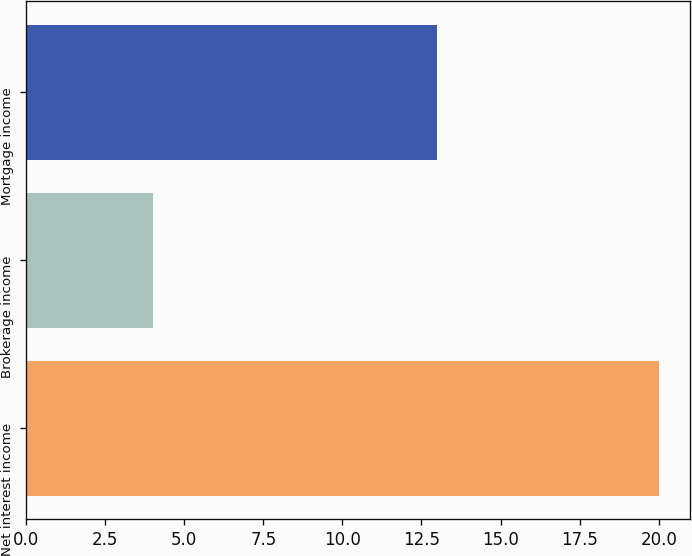<chart> <loc_0><loc_0><loc_500><loc_500><bar_chart><fcel>Net interest income<fcel>Brokerage income<fcel>Mortgage income<nl><fcel>20<fcel>4<fcel>13<nl></chart> 